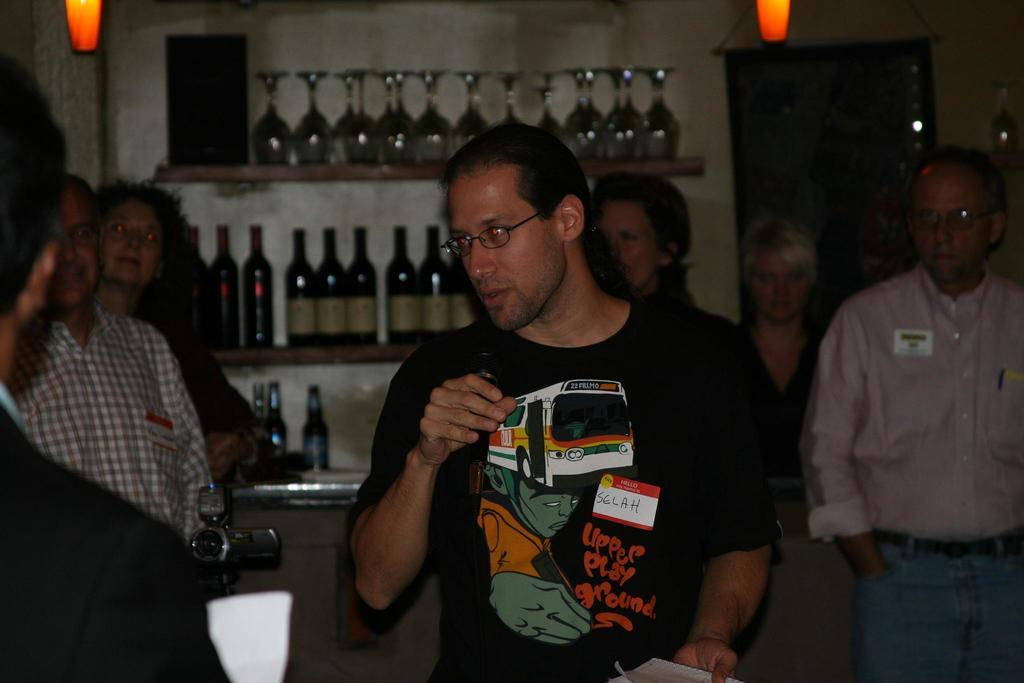What is happening in the image? There are people standing in the image. What are the people wearing? The people are wearing clothes. Can you describe any accessories the people are wearing? Some of the people are wearing spectacles. What equipment is visible in the image? There is a video camera in the image. What type of furniture is present in the image? There is a shelf in the image. What items can be seen on the shelf? There are bottles in the image. What type of glassware is visible in the image? There is a wine glass in the image. What source of light is present in the image? There is a light in the image. How many dogs are present in the image? There are no dogs present in the image. What type of leaf is being used as a prop in the image? There is no leaf present in the image. 